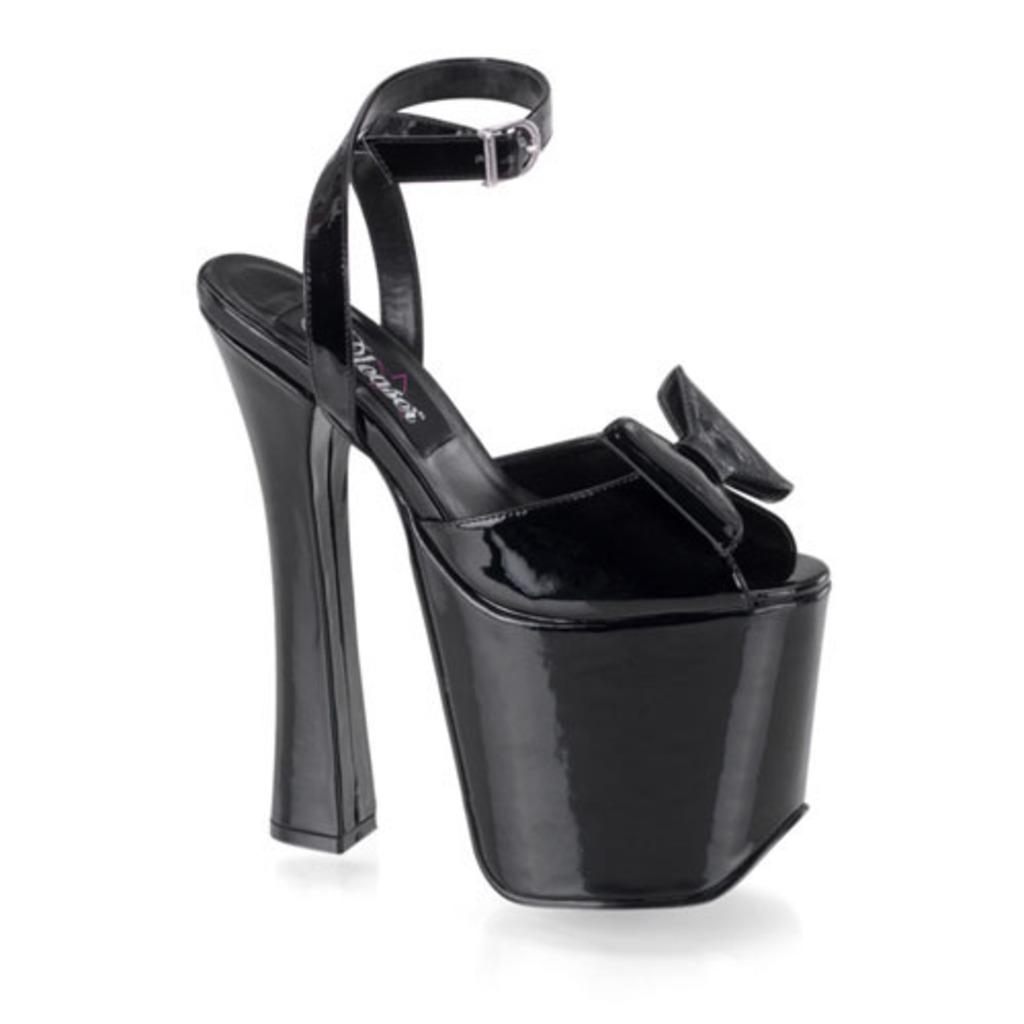What is the main subject of the image? The main subject of the image is a black heel. Can you describe the background of the image? The background of the image is white. What type of rice can be seen in the image? There is no rice present in the image; it features a black heel on a white background. How many boats are visible in the harbor in the image? There is no harbor or boats present in the image; it features a black heel on a white background. 